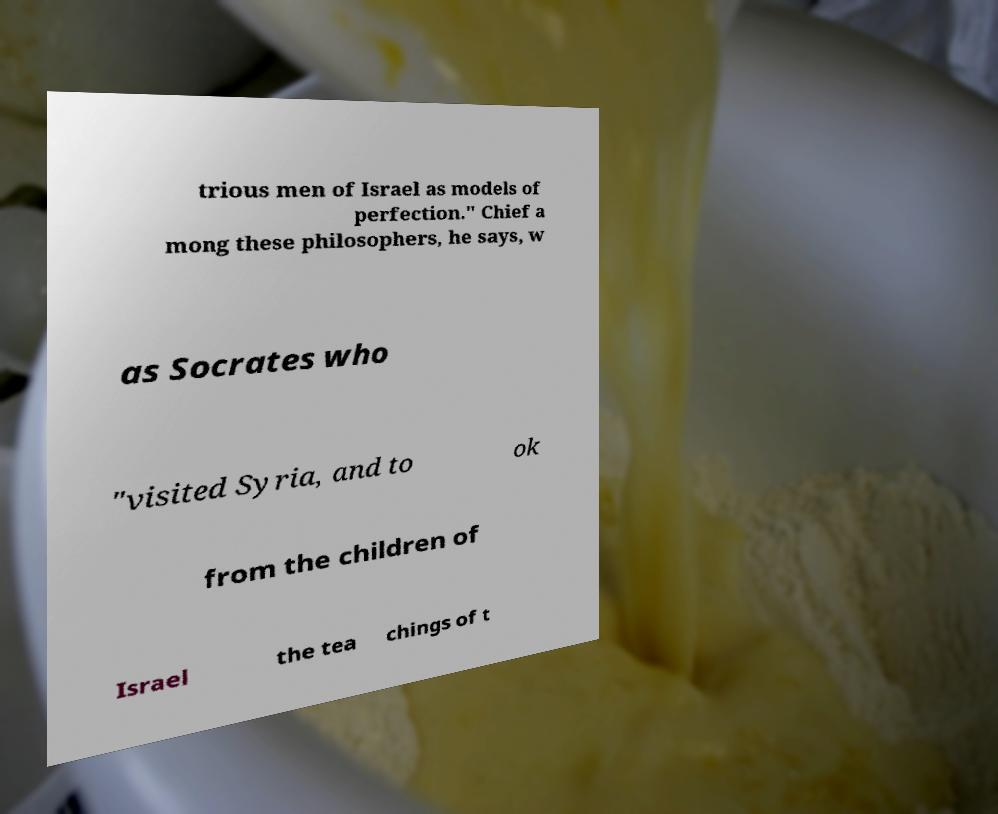Could you assist in decoding the text presented in this image and type it out clearly? trious men of Israel as models of perfection." Chief a mong these philosophers, he says, w as Socrates who "visited Syria, and to ok from the children of Israel the tea chings of t 